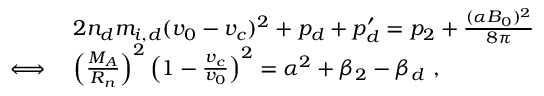<formula> <loc_0><loc_0><loc_500><loc_500>\begin{array} { r l } & { 2 n _ { d } m _ { i , d } ( v _ { 0 } - v _ { c } ) ^ { 2 } + p _ { d } + p _ { d } ^ { \prime } = p _ { 2 } + \frac { ( \alpha B _ { 0 } ) ^ { 2 } } { 8 \pi } } \\ { \iff } & { \left ( \frac { M _ { A } } { R _ { n } } \right ) ^ { 2 } \left ( 1 - \frac { v _ { c } } { v _ { 0 } } \right ) ^ { 2 } = \alpha ^ { 2 } + \beta _ { 2 } - \beta _ { d } \ , } \end{array}</formula> 